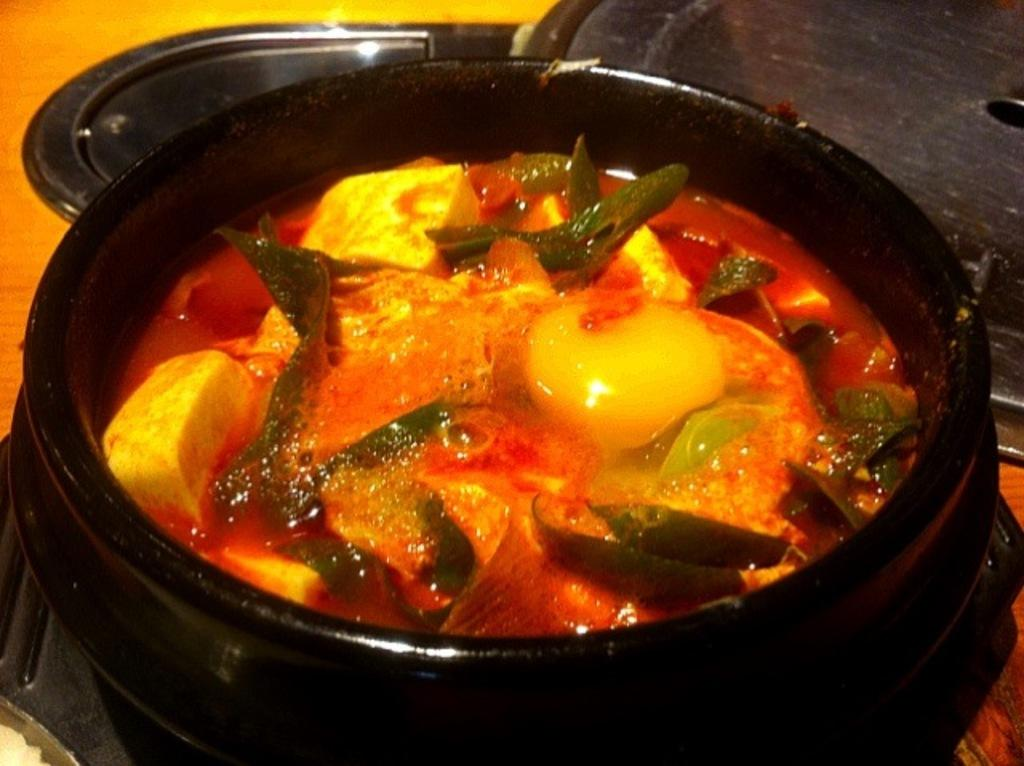What color is the bowl that is visible in the image? There is a black bowl in the image. What is inside the black bowl? The black bowl contains pasta curry. What is another dish-like object present in the image? There is a plate in the image. What other objects can be seen on the table in the image? There are other objects on the table in the image. What type of bait is used for fishing in the image? There is no fishing or bait present in the image; it features a black bowl containing pasta curry and a plate on a table. 